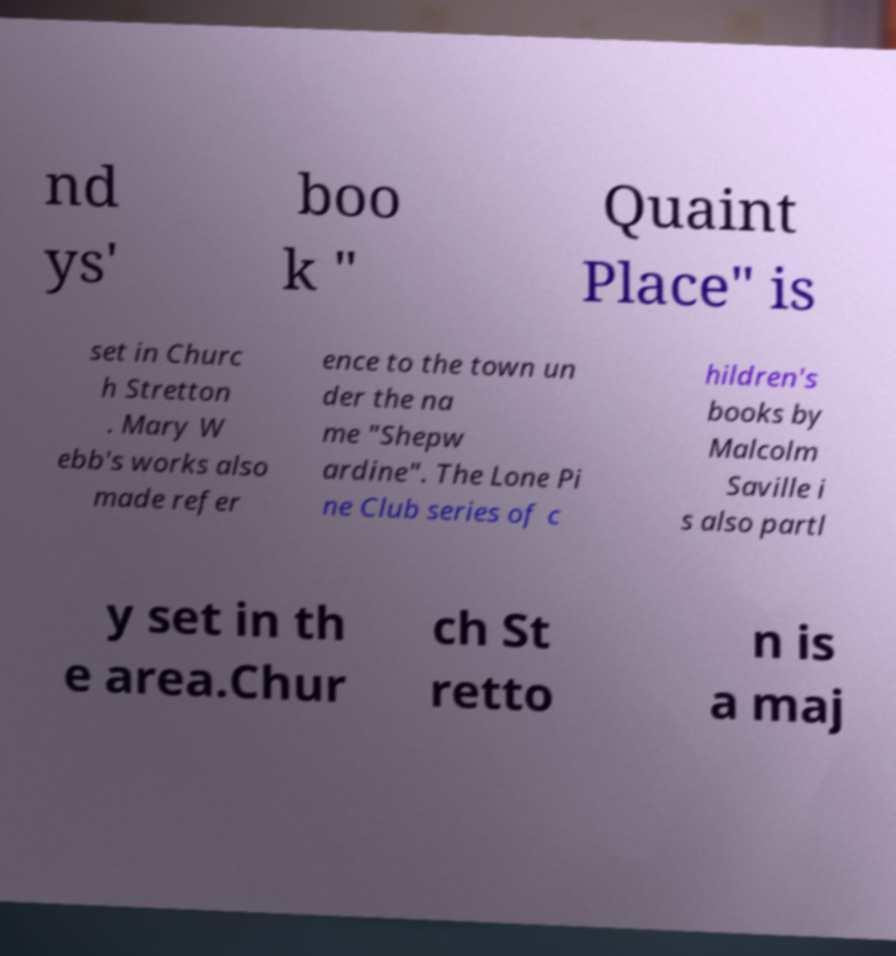Please identify and transcribe the text found in this image. nd ys' boo k " Quaint Place" is set in Churc h Stretton . Mary W ebb's works also made refer ence to the town un der the na me "Shepw ardine". The Lone Pi ne Club series of c hildren's books by Malcolm Saville i s also partl y set in th e area.Chur ch St retto n is a maj 